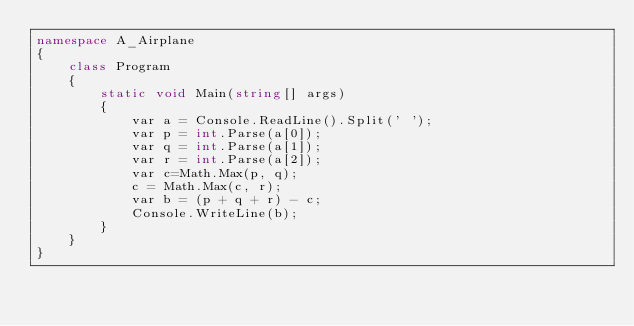Convert code to text. <code><loc_0><loc_0><loc_500><loc_500><_C#_>namespace A_Airplane
{
    class Program
    {
        static void Main(string[] args)
        {
            var a = Console.ReadLine().Split(' ');
            var p = int.Parse(a[0]);
            var q = int.Parse(a[1]);
            var r = int.Parse(a[2]);
            var c=Math.Max(p, q);
            c = Math.Max(c, r);
            var b = (p + q + r) - c;
            Console.WriteLine(b);
        }
    }
}</code> 